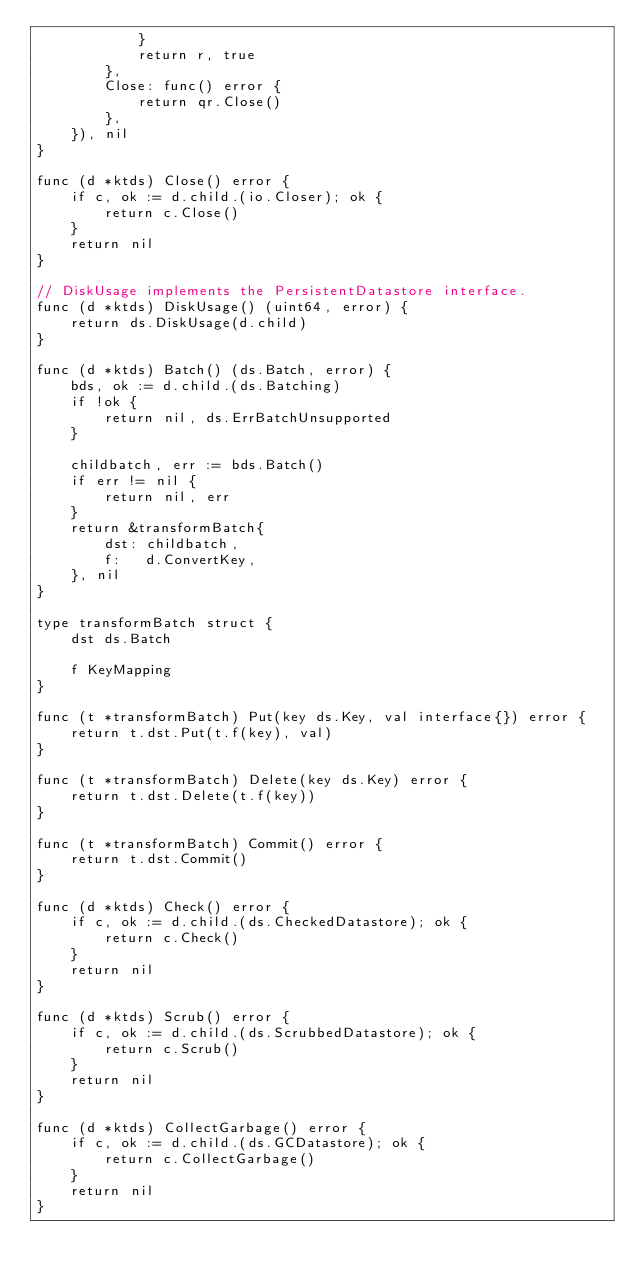<code> <loc_0><loc_0><loc_500><loc_500><_Go_>			}
			return r, true
		},
		Close: func() error {
			return qr.Close()
		},
	}), nil
}

func (d *ktds) Close() error {
	if c, ok := d.child.(io.Closer); ok {
		return c.Close()
	}
	return nil
}

// DiskUsage implements the PersistentDatastore interface.
func (d *ktds) DiskUsage() (uint64, error) {
	return ds.DiskUsage(d.child)
}

func (d *ktds) Batch() (ds.Batch, error) {
	bds, ok := d.child.(ds.Batching)
	if !ok {
		return nil, ds.ErrBatchUnsupported
	}

	childbatch, err := bds.Batch()
	if err != nil {
		return nil, err
	}
	return &transformBatch{
		dst: childbatch,
		f:   d.ConvertKey,
	}, nil
}

type transformBatch struct {
	dst ds.Batch

	f KeyMapping
}

func (t *transformBatch) Put(key ds.Key, val interface{}) error {
	return t.dst.Put(t.f(key), val)
}

func (t *transformBatch) Delete(key ds.Key) error {
	return t.dst.Delete(t.f(key))
}

func (t *transformBatch) Commit() error {
	return t.dst.Commit()
}

func (d *ktds) Check() error {
	if c, ok := d.child.(ds.CheckedDatastore); ok {
		return c.Check()
	}
	return nil
}

func (d *ktds) Scrub() error {
	if c, ok := d.child.(ds.ScrubbedDatastore); ok {
		return c.Scrub()
	}
	return nil
}

func (d *ktds) CollectGarbage() error {
	if c, ok := d.child.(ds.GCDatastore); ok {
		return c.CollectGarbage()
	}
	return nil
}
</code> 